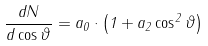Convert formula to latex. <formula><loc_0><loc_0><loc_500><loc_500>\frac { d N } { d \cos \vartheta } = a _ { 0 } \cdot \left ( 1 + a _ { 2 } \cos ^ { 2 } \vartheta \right )</formula> 